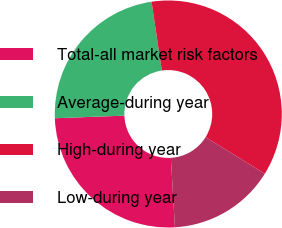<chart> <loc_0><loc_0><loc_500><loc_500><pie_chart><fcel>Total-all market risk factors<fcel>Average-during year<fcel>High-during year<fcel>Low-during year<nl><fcel>25.34%<fcel>23.25%<fcel>36.18%<fcel>15.24%<nl></chart> 